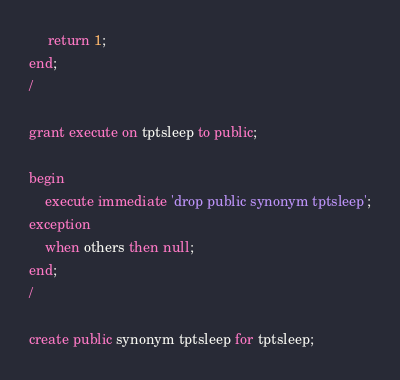Convert code to text. <code><loc_0><loc_0><loc_500><loc_500><_SQL_>     return 1;
end;
/

grant execute on tptsleep to public;

begin
    execute immediate 'drop public synonym tptsleep';
exception
    when others then null;
end;
/

create public synonym tptsleep for tptsleep;
</code> 